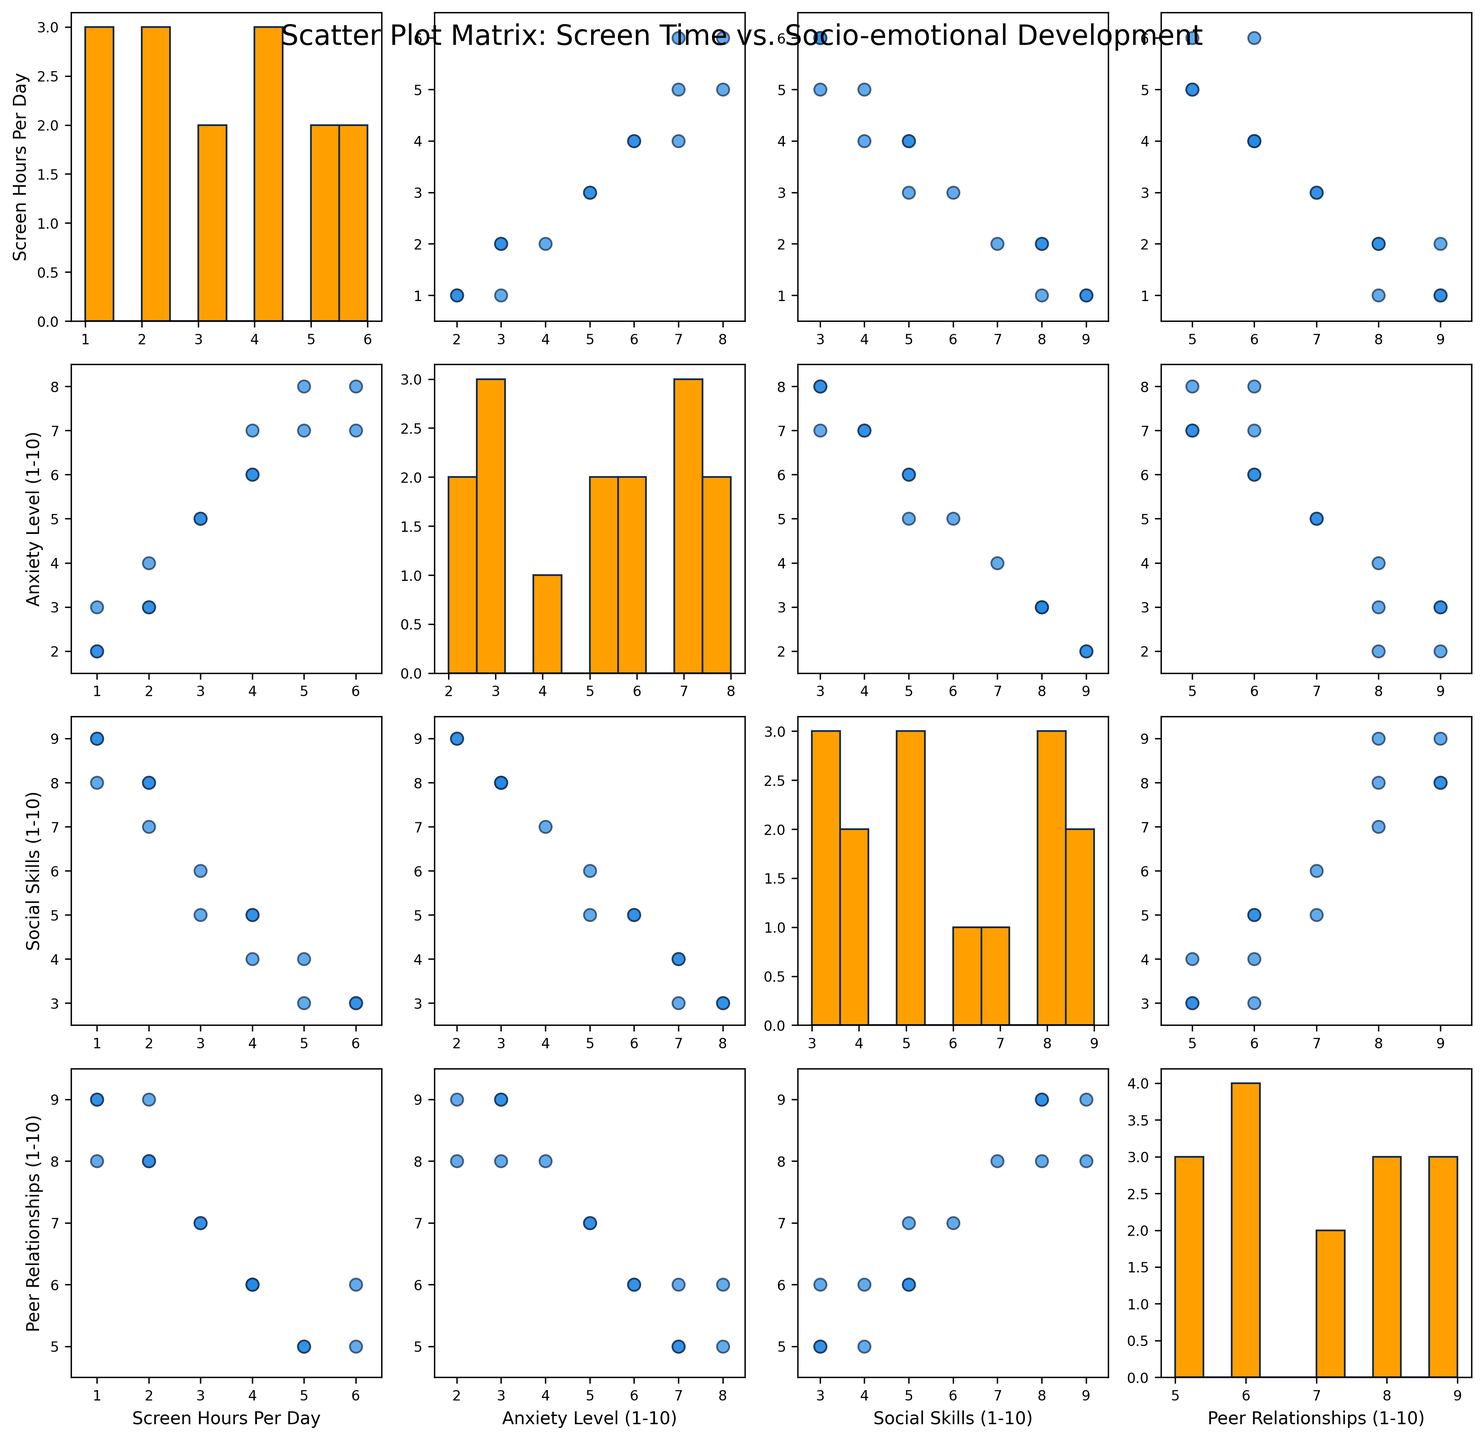What is the title of the figure? The title is written at the top of the figure, usually in a larger font. It summarizes what the figure is about.
Answer: Scatter Plot Matrix: Screen Time vs. Socio-emotional Development How many variables are being compared in the SPLOM? The variables are listed along the axes of the scatter plot matrix. Count the unique variables mentioned.
Answer: Four What does the scatter plot in the first row and second column represent? Each cell in the matrix represents a scatter plot comparing two variables. The first row and second column compare the first variable (Screen Hours Per Day) with the second variable (Anxiety Level).
Answer: Screen Hours Per Day vs. Anxiety Level Which pair of variables shows the most distinct linear relationship, if any? Look for scatter plots with a discernible pattern, like a line. Identify the variables from the corresponding row and column.
Answer: Screen Hours Per Day vs. Anxiety Level Is there a visible trend between Screen Hours Per Day and Social Skills (1-10)? Examine the scatter plot comparing these two variables. Look for any visible pattern, such as a positive or negative correlation.
Answer: Negative correlation Which variable seems to have the highest range of values? Compare the ranges of the histograms on the diagonal of the matrix. Notice which variable histograms span the largest number of bins.
Answer: Anxiety Level (1-10) What can be inferred about the relationship between Peer Relationships (1-10) and Social Skills (1-10)? Examine the scatter plot comparing these two variables. Look for clusters, trends, or patterns that indicate a relationship.
Answer: Positive correlation Does the scatter plot matrix suggest any outliers for Screen Hours Per Day? Look at scatter plots involving Screen Hours Per Day. Identify any points significantly outside the general cluster of data.
Answer: Yes What does the histogram on the diagonal for Anxiety Level (1-10) indicate about the distribution of this variable? Histograms on the diagonal show the frequency distribution of each variable. Analyze the shape, spread, and central tendency of the histogram for Anxiety Level (1-10).
Answer: Positively skewed distribution 